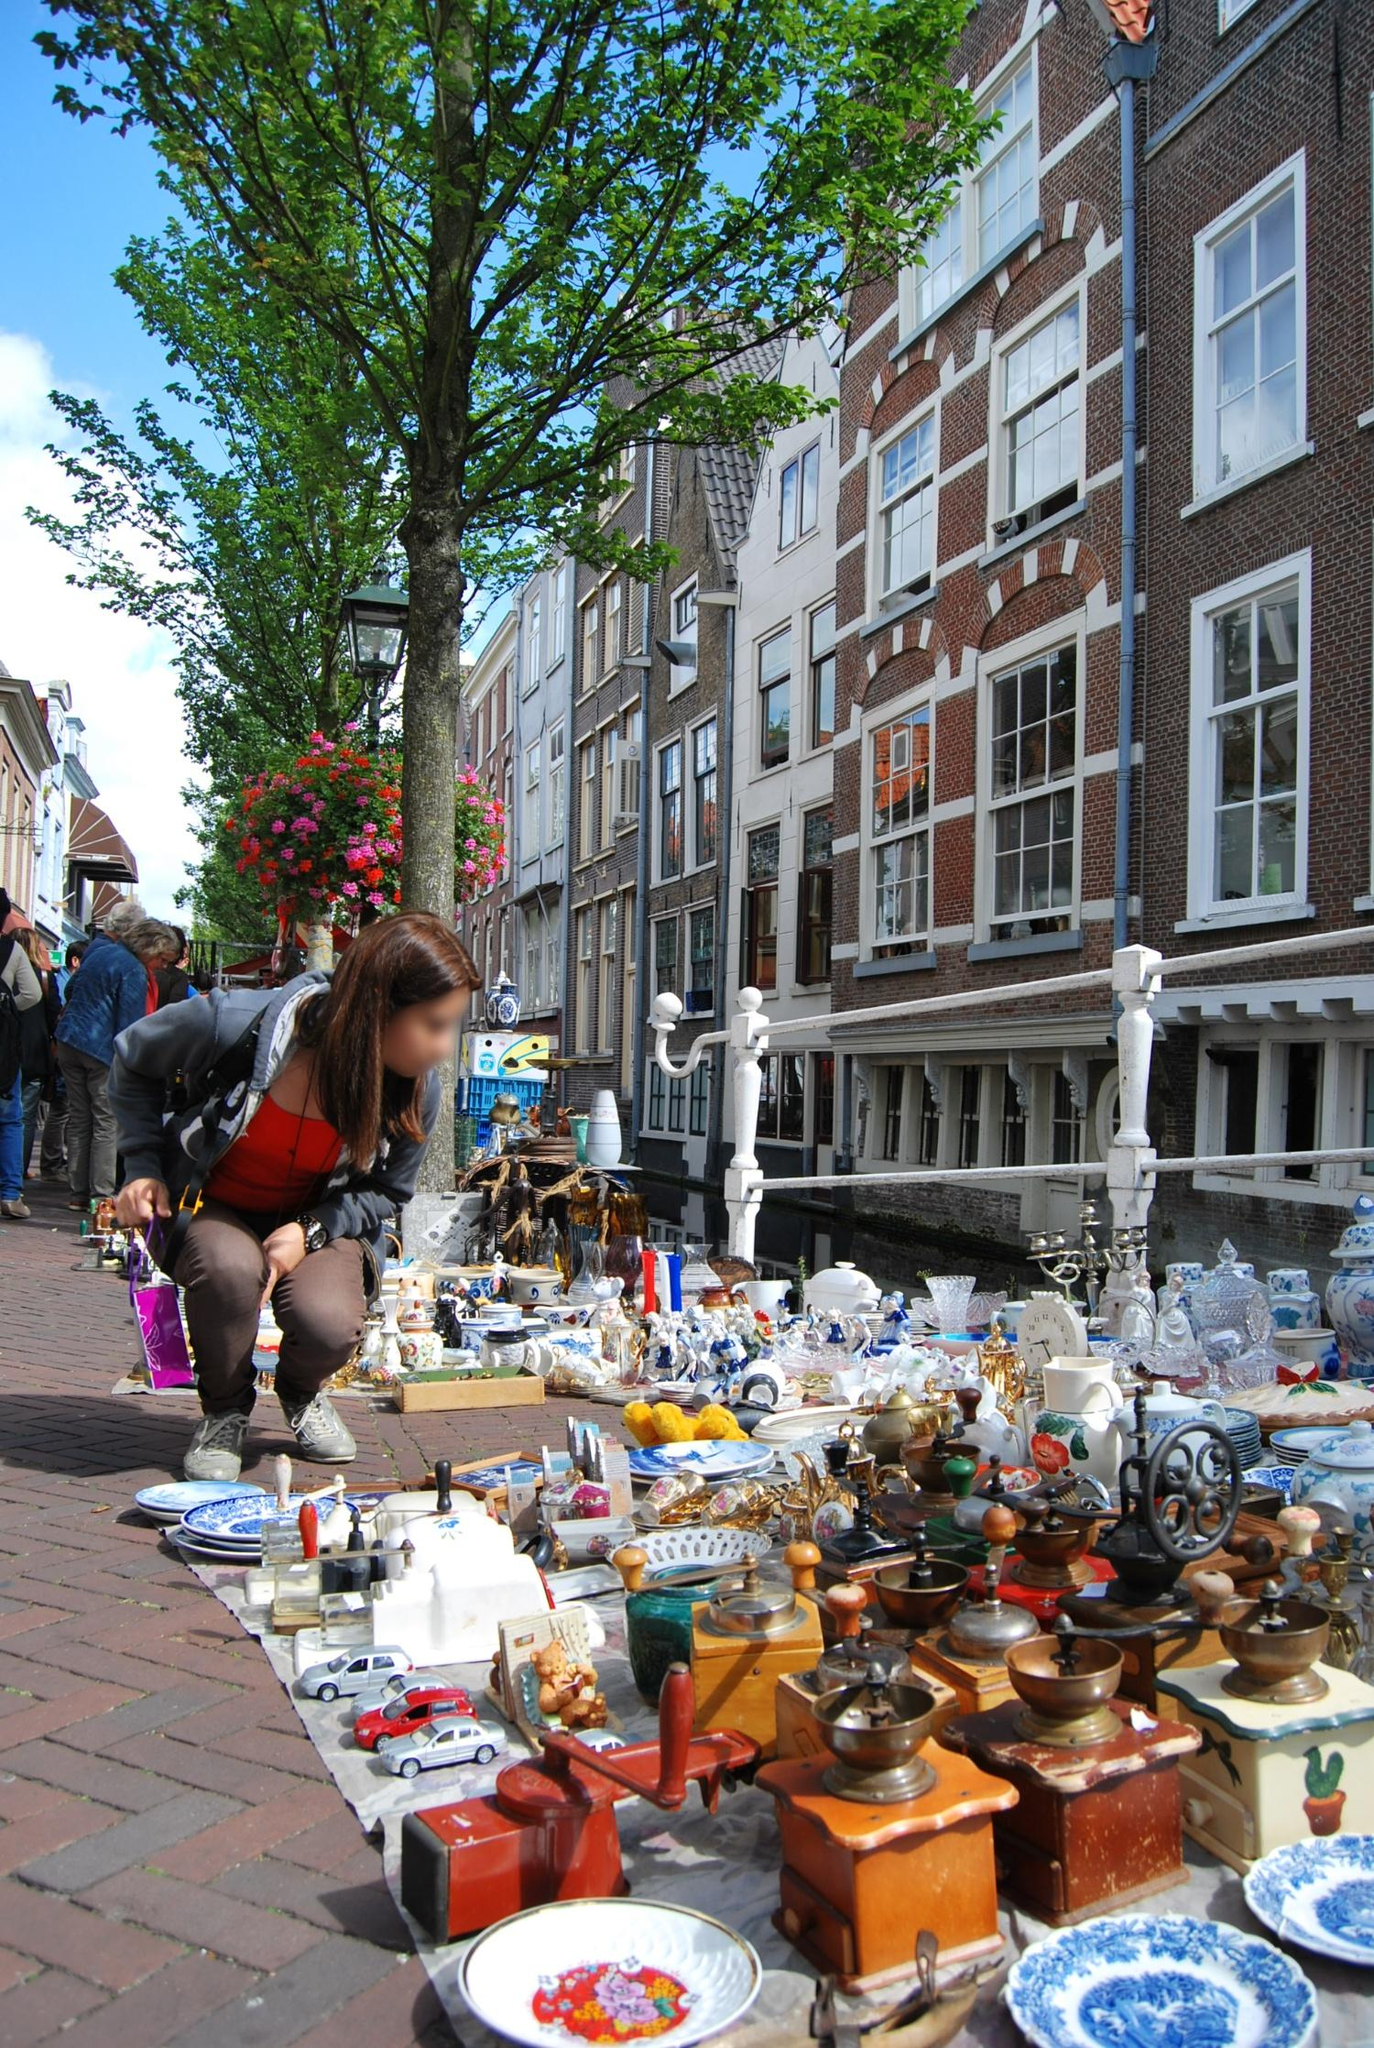Describe how the bustling market atmosphere in the image compares to modern-day street markets in Amsterdam. The bustling market atmosphere depicted in the image is strikingly similar to what you would experience at modern-day street markets in Amsterdam. The city teems with various outdoor markets, such as the Albert Cuyp Market and the Waterlooplein Flea Market, known for their vibrant and lively settings. These markets bring together a mix of locals and tourists, all eager to explore the vast array of goods on offer.

Modern markets continue the tradition of providing a diverse range of items, from fresh produce, cheese, and flowers to vintage clothing, antiques, and artisanal crafts. The sense of community and the habit of leisurely browsing through the stalls contribute to the enduring charm of Amsterdam's street markets. What has evolved is the range of goods available, reflecting contemporary tastes while preserving the city's rich market heritage. 